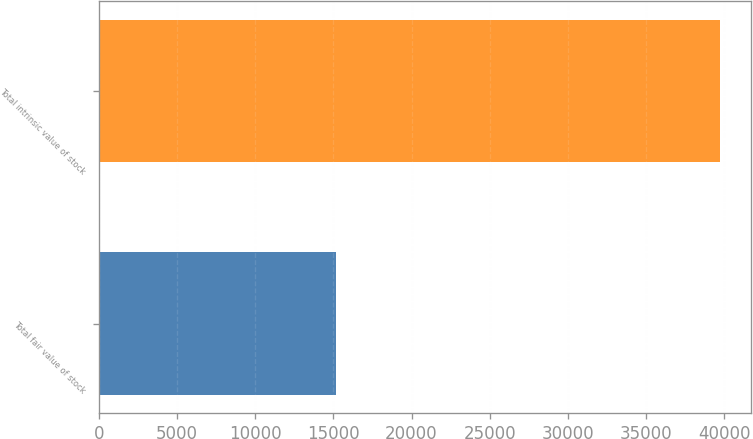Convert chart to OTSL. <chart><loc_0><loc_0><loc_500><loc_500><bar_chart><fcel>Total fair value of stock<fcel>Total intrinsic value of stock<nl><fcel>15184<fcel>39696<nl></chart> 